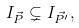Convert formula to latex. <formula><loc_0><loc_0><loc_500><loc_500>I _ { \vec { P } } \subsetneq I _ { \vec { P ^ { \prime } } } ,</formula> 